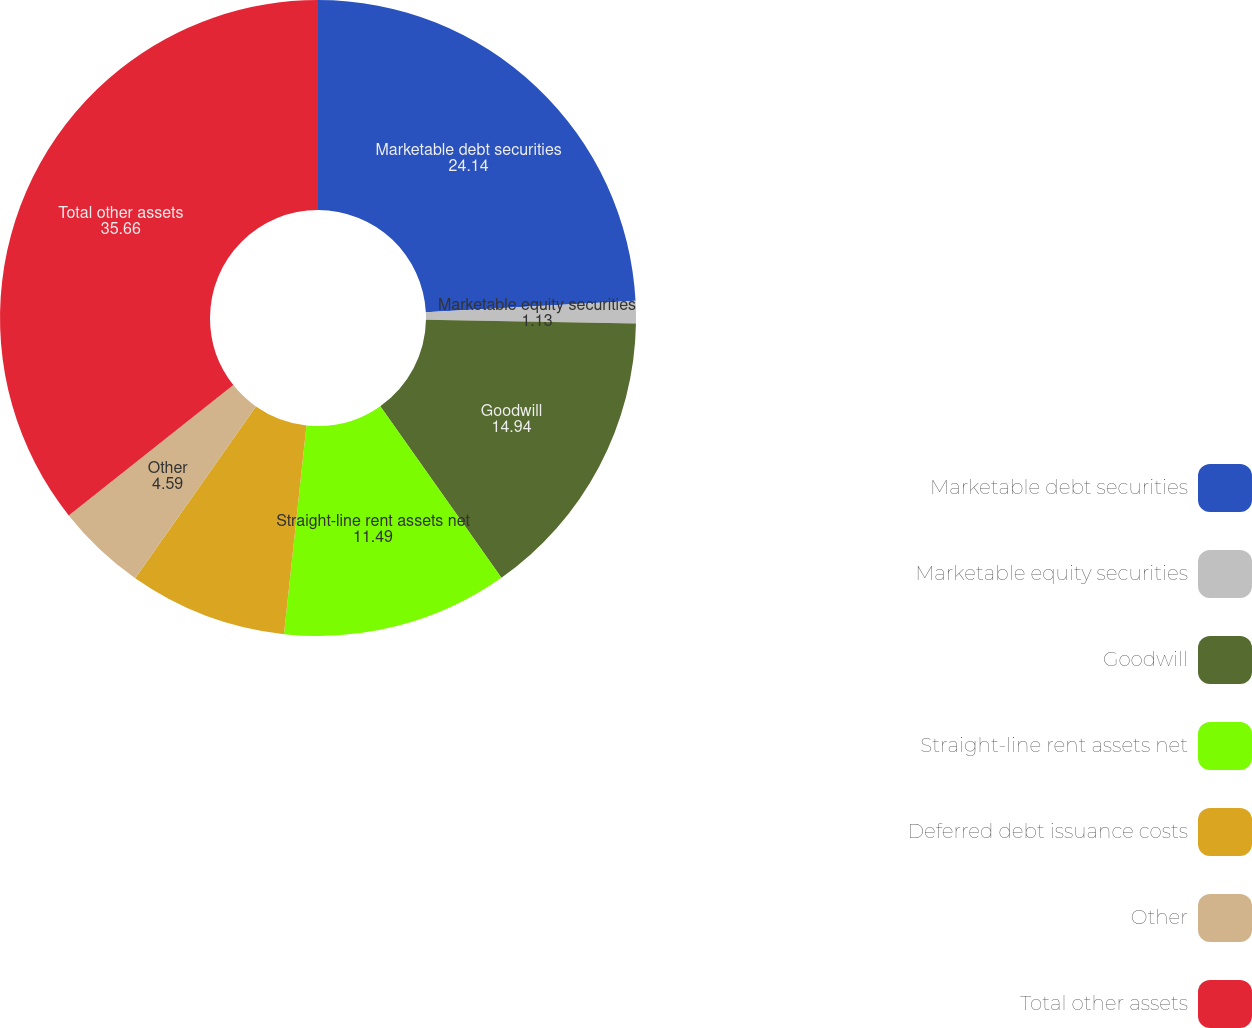Convert chart. <chart><loc_0><loc_0><loc_500><loc_500><pie_chart><fcel>Marketable debt securities<fcel>Marketable equity securities<fcel>Goodwill<fcel>Straight-line rent assets net<fcel>Deferred debt issuance costs<fcel>Other<fcel>Total other assets<nl><fcel>24.14%<fcel>1.13%<fcel>14.94%<fcel>11.49%<fcel>8.04%<fcel>4.59%<fcel>35.66%<nl></chart> 